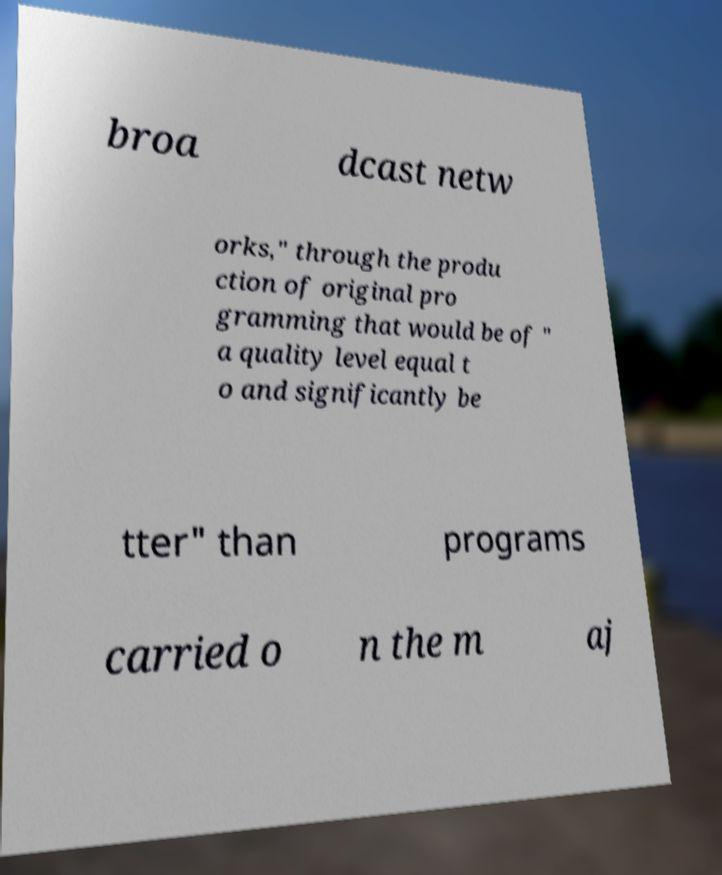Could you assist in decoding the text presented in this image and type it out clearly? broa dcast netw orks," through the produ ction of original pro gramming that would be of " a quality level equal t o and significantly be tter" than programs carried o n the m aj 